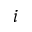Convert formula to latex. <formula><loc_0><loc_0><loc_500><loc_500>i</formula> 